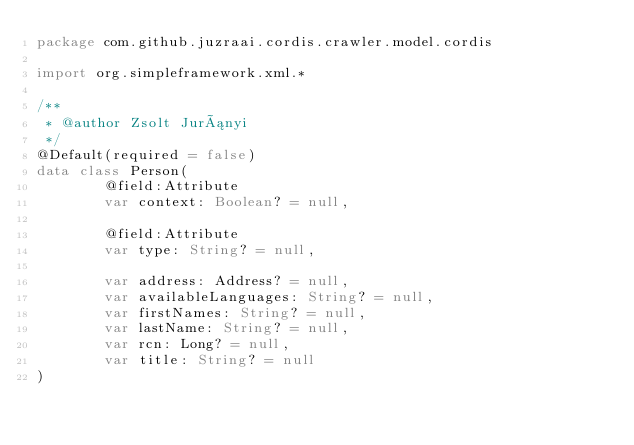Convert code to text. <code><loc_0><loc_0><loc_500><loc_500><_Kotlin_>package com.github.juzraai.cordis.crawler.model.cordis

import org.simpleframework.xml.*

/**
 * @author Zsolt Jurányi
 */
@Default(required = false)
data class Person(
		@field:Attribute
		var context: Boolean? = null,

		@field:Attribute
		var type: String? = null,

		var address: Address? = null,
		var availableLanguages: String? = null,
		var firstNames: String? = null,
		var lastName: String? = null,
		var rcn: Long? = null,
		var title: String? = null
)</code> 